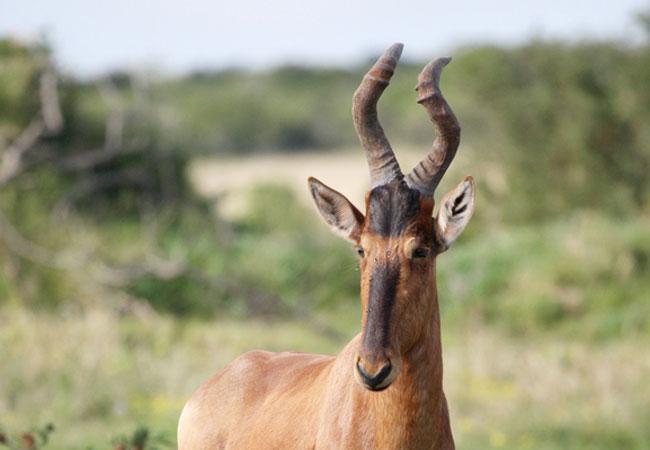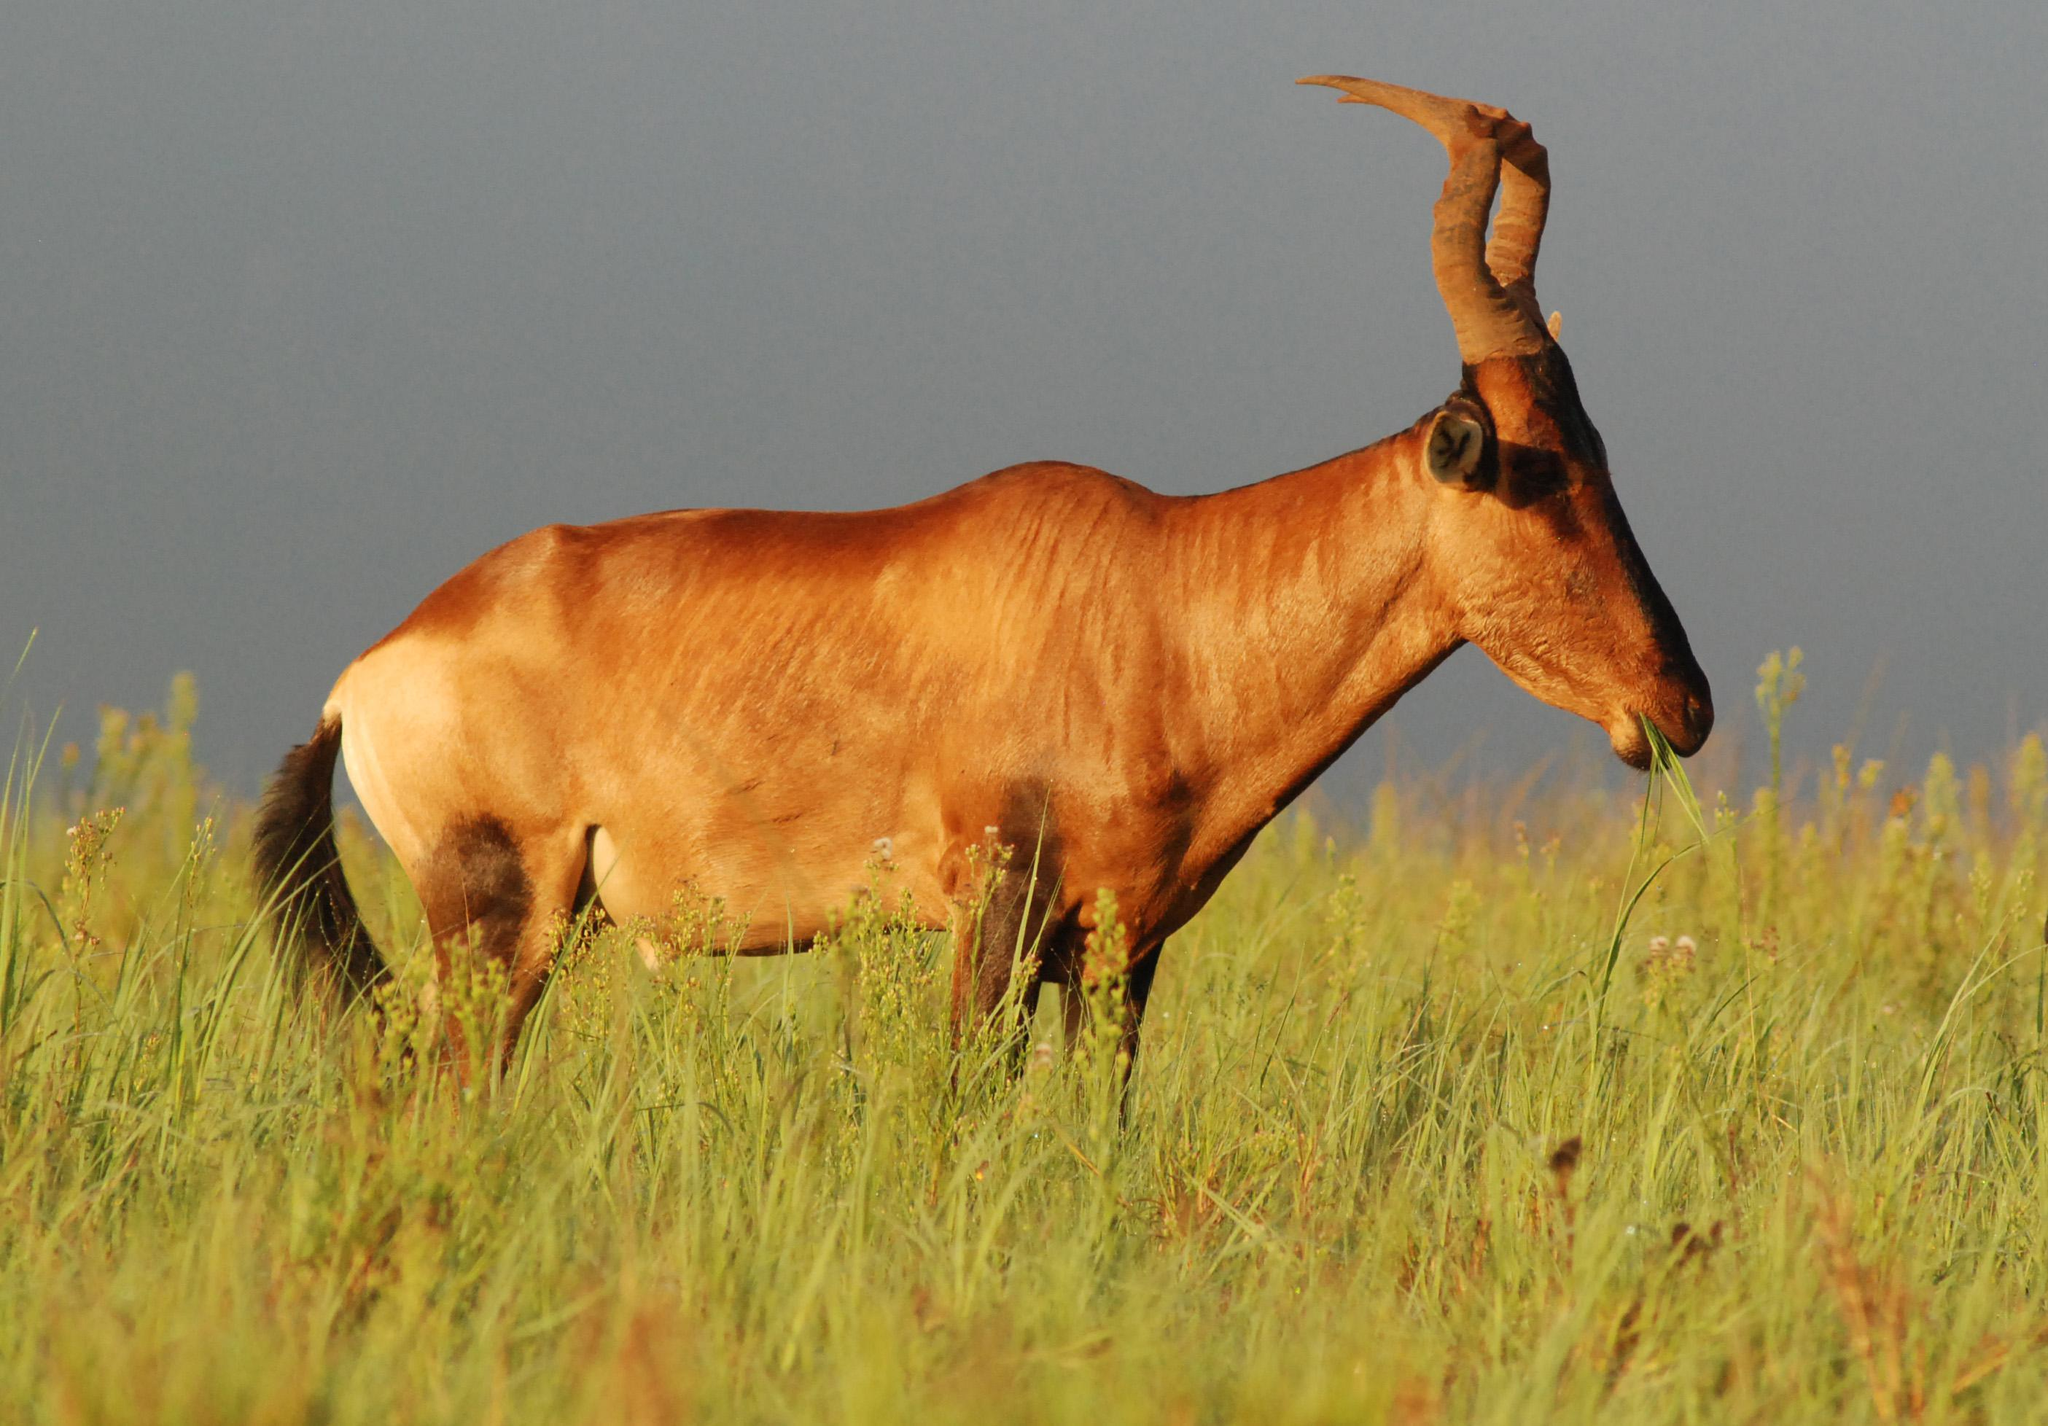The first image is the image on the left, the second image is the image on the right. Evaluate the accuracy of this statement regarding the images: "Exactly one animal is lying on the ground.". Is it true? Answer yes or no. No. The first image is the image on the left, the second image is the image on the right. Evaluate the accuracy of this statement regarding the images: "In one image, a hunter in a hat holding a rifle vertically is behind a downed horned animal with its head to the right.". Is it true? Answer yes or no. No. 